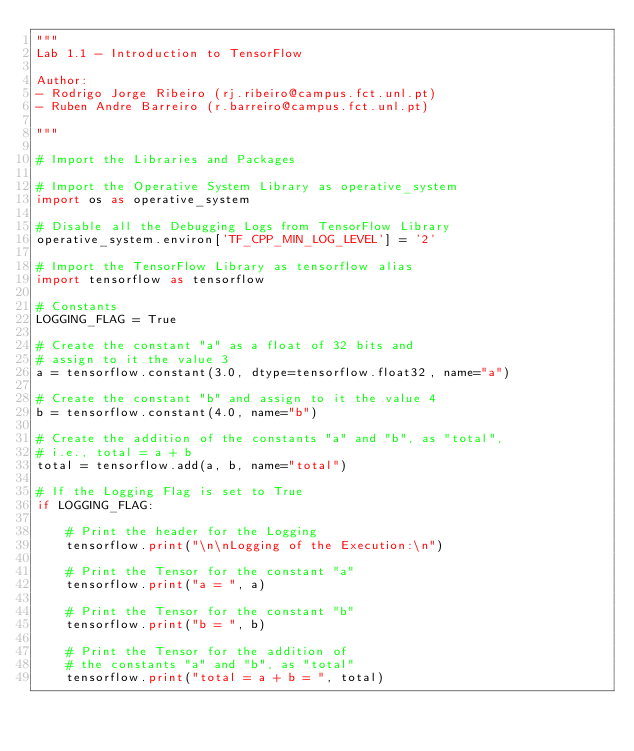Convert code to text. <code><loc_0><loc_0><loc_500><loc_500><_Python_>"""
Lab 1.1 - Introduction to TensorFlow

Author:
- Rodrigo Jorge Ribeiro (rj.ribeiro@campus.fct.unl.pt)
- Ruben Andre Barreiro (r.barreiro@campus.fct.unl.pt)

"""

# Import the Libraries and Packages

# Import the Operative System Library as operative_system
import os as operative_system

# Disable all the Debugging Logs from TensorFlow Library
operative_system.environ['TF_CPP_MIN_LOG_LEVEL'] = '2'

# Import the TensorFlow Library as tensorflow alias
import tensorflow as tensorflow

# Constants
LOGGING_FLAG = True

# Create the constant "a" as a float of 32 bits and
# assign to it the value 3
a = tensorflow.constant(3.0, dtype=tensorflow.float32, name="a")

# Create the constant "b" and assign to it the value 4
b = tensorflow.constant(4.0, name="b")

# Create the addition of the constants "a" and "b", as "total",
# i.e., total = a + b
total = tensorflow.add(a, b, name="total")

# If the Logging Flag is set to True
if LOGGING_FLAG:

    # Print the header for the Logging
    tensorflow.print("\n\nLogging of the Execution:\n")

    # Print the Tensor for the constant "a"
    tensorflow.print("a = ", a)

    # Print the Tensor for the constant "b"
    tensorflow.print("b = ", b)

    # Print the Tensor for the addition of
    # the constants "a" and "b", as "total"
    tensorflow.print("total = a + b = ", total)
</code> 